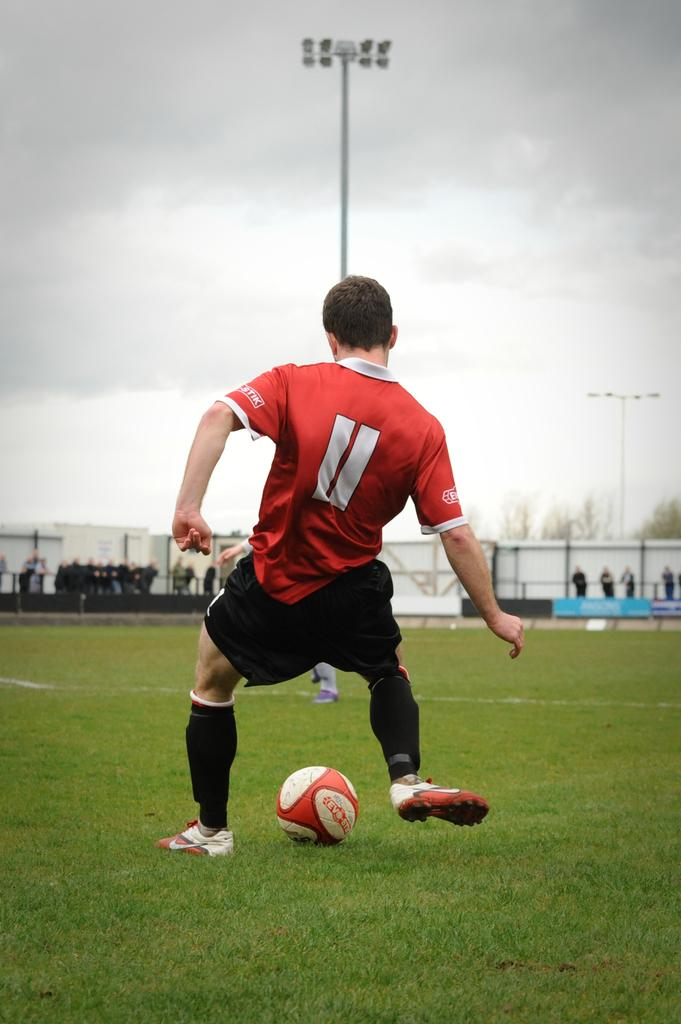<image>
Give a short and clear explanation of the subsequent image. A man playing soccer in an orange jesrsey with the number 11. 